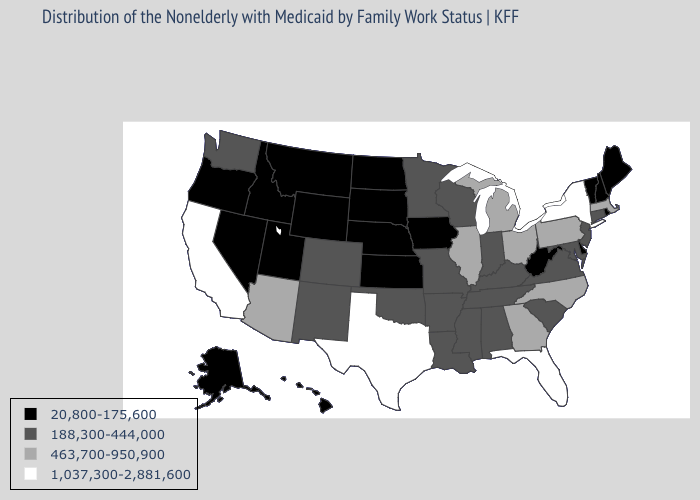What is the value of Alaska?
Concise answer only. 20,800-175,600. What is the highest value in the Northeast ?
Concise answer only. 1,037,300-2,881,600. What is the value of Idaho?
Short answer required. 20,800-175,600. What is the value of Florida?
Give a very brief answer. 1,037,300-2,881,600. What is the highest value in the Northeast ?
Write a very short answer. 1,037,300-2,881,600. Name the states that have a value in the range 1,037,300-2,881,600?
Answer briefly. California, Florida, New York, Texas. Name the states that have a value in the range 188,300-444,000?
Quick response, please. Alabama, Arkansas, Colorado, Connecticut, Indiana, Kentucky, Louisiana, Maryland, Minnesota, Mississippi, Missouri, New Jersey, New Mexico, Oklahoma, South Carolina, Tennessee, Virginia, Washington, Wisconsin. What is the value of Hawaii?
Concise answer only. 20,800-175,600. Among the states that border Mississippi , which have the highest value?
Give a very brief answer. Alabama, Arkansas, Louisiana, Tennessee. Does North Carolina have a higher value than Indiana?
Concise answer only. Yes. What is the highest value in states that border Arizona?
Be succinct. 1,037,300-2,881,600. Name the states that have a value in the range 1,037,300-2,881,600?
Answer briefly. California, Florida, New York, Texas. What is the highest value in states that border New Hampshire?
Give a very brief answer. 463,700-950,900. What is the value of Texas?
Short answer required. 1,037,300-2,881,600. Name the states that have a value in the range 188,300-444,000?
Short answer required. Alabama, Arkansas, Colorado, Connecticut, Indiana, Kentucky, Louisiana, Maryland, Minnesota, Mississippi, Missouri, New Jersey, New Mexico, Oklahoma, South Carolina, Tennessee, Virginia, Washington, Wisconsin. 